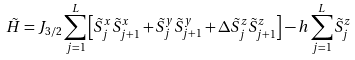<formula> <loc_0><loc_0><loc_500><loc_500>\tilde { H } = J _ { 3 / 2 } \sum _ { j = 1 } ^ { L } \left [ \tilde { S } _ { j } ^ { x } \tilde { S } _ { j + 1 } ^ { x } + \tilde { S } _ { j } ^ { y } \tilde { S } _ { j + 1 } ^ { y } + \Delta \tilde { S } _ { j } ^ { z } \tilde { S } _ { j + 1 } ^ { z } \right ] - h \sum _ { j = 1 } ^ { L } \tilde { S } _ { j } ^ { z }</formula> 